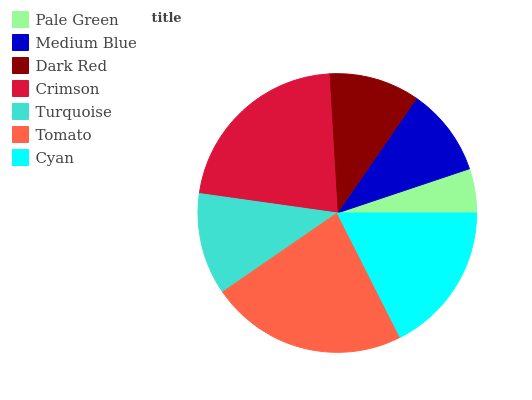Is Pale Green the minimum?
Answer yes or no. Yes. Is Tomato the maximum?
Answer yes or no. Yes. Is Medium Blue the minimum?
Answer yes or no. No. Is Medium Blue the maximum?
Answer yes or no. No. Is Medium Blue greater than Pale Green?
Answer yes or no. Yes. Is Pale Green less than Medium Blue?
Answer yes or no. Yes. Is Pale Green greater than Medium Blue?
Answer yes or no. No. Is Medium Blue less than Pale Green?
Answer yes or no. No. Is Turquoise the high median?
Answer yes or no. Yes. Is Turquoise the low median?
Answer yes or no. Yes. Is Medium Blue the high median?
Answer yes or no. No. Is Cyan the low median?
Answer yes or no. No. 